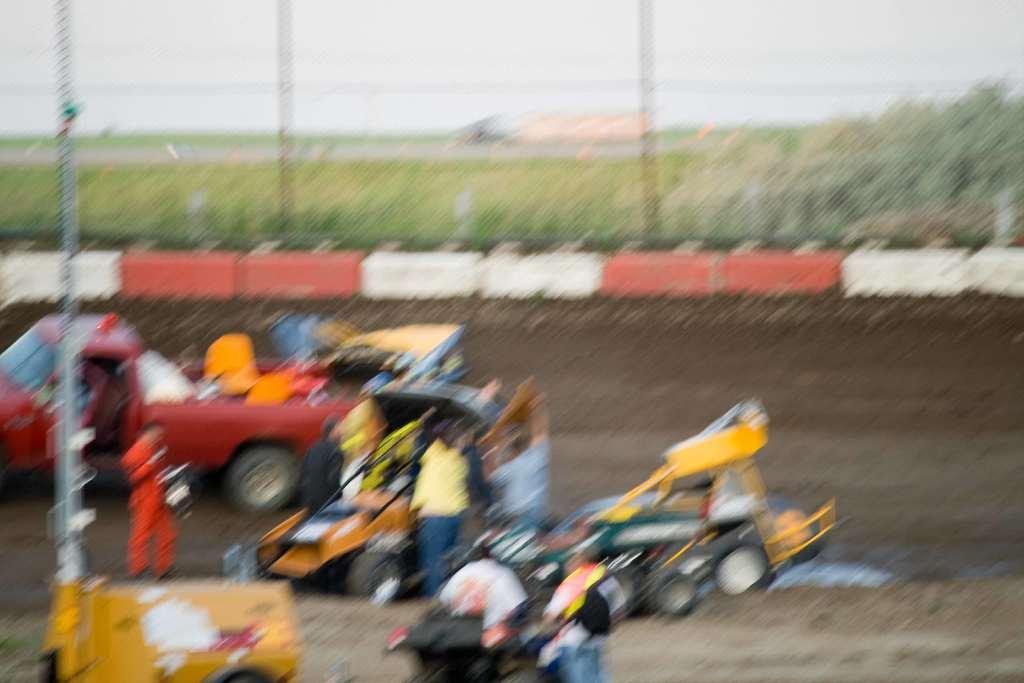Could you give a brief overview of what you see in this image? In this image we can see people standing on the ground, motor vehicles, poles, trees and sky. 